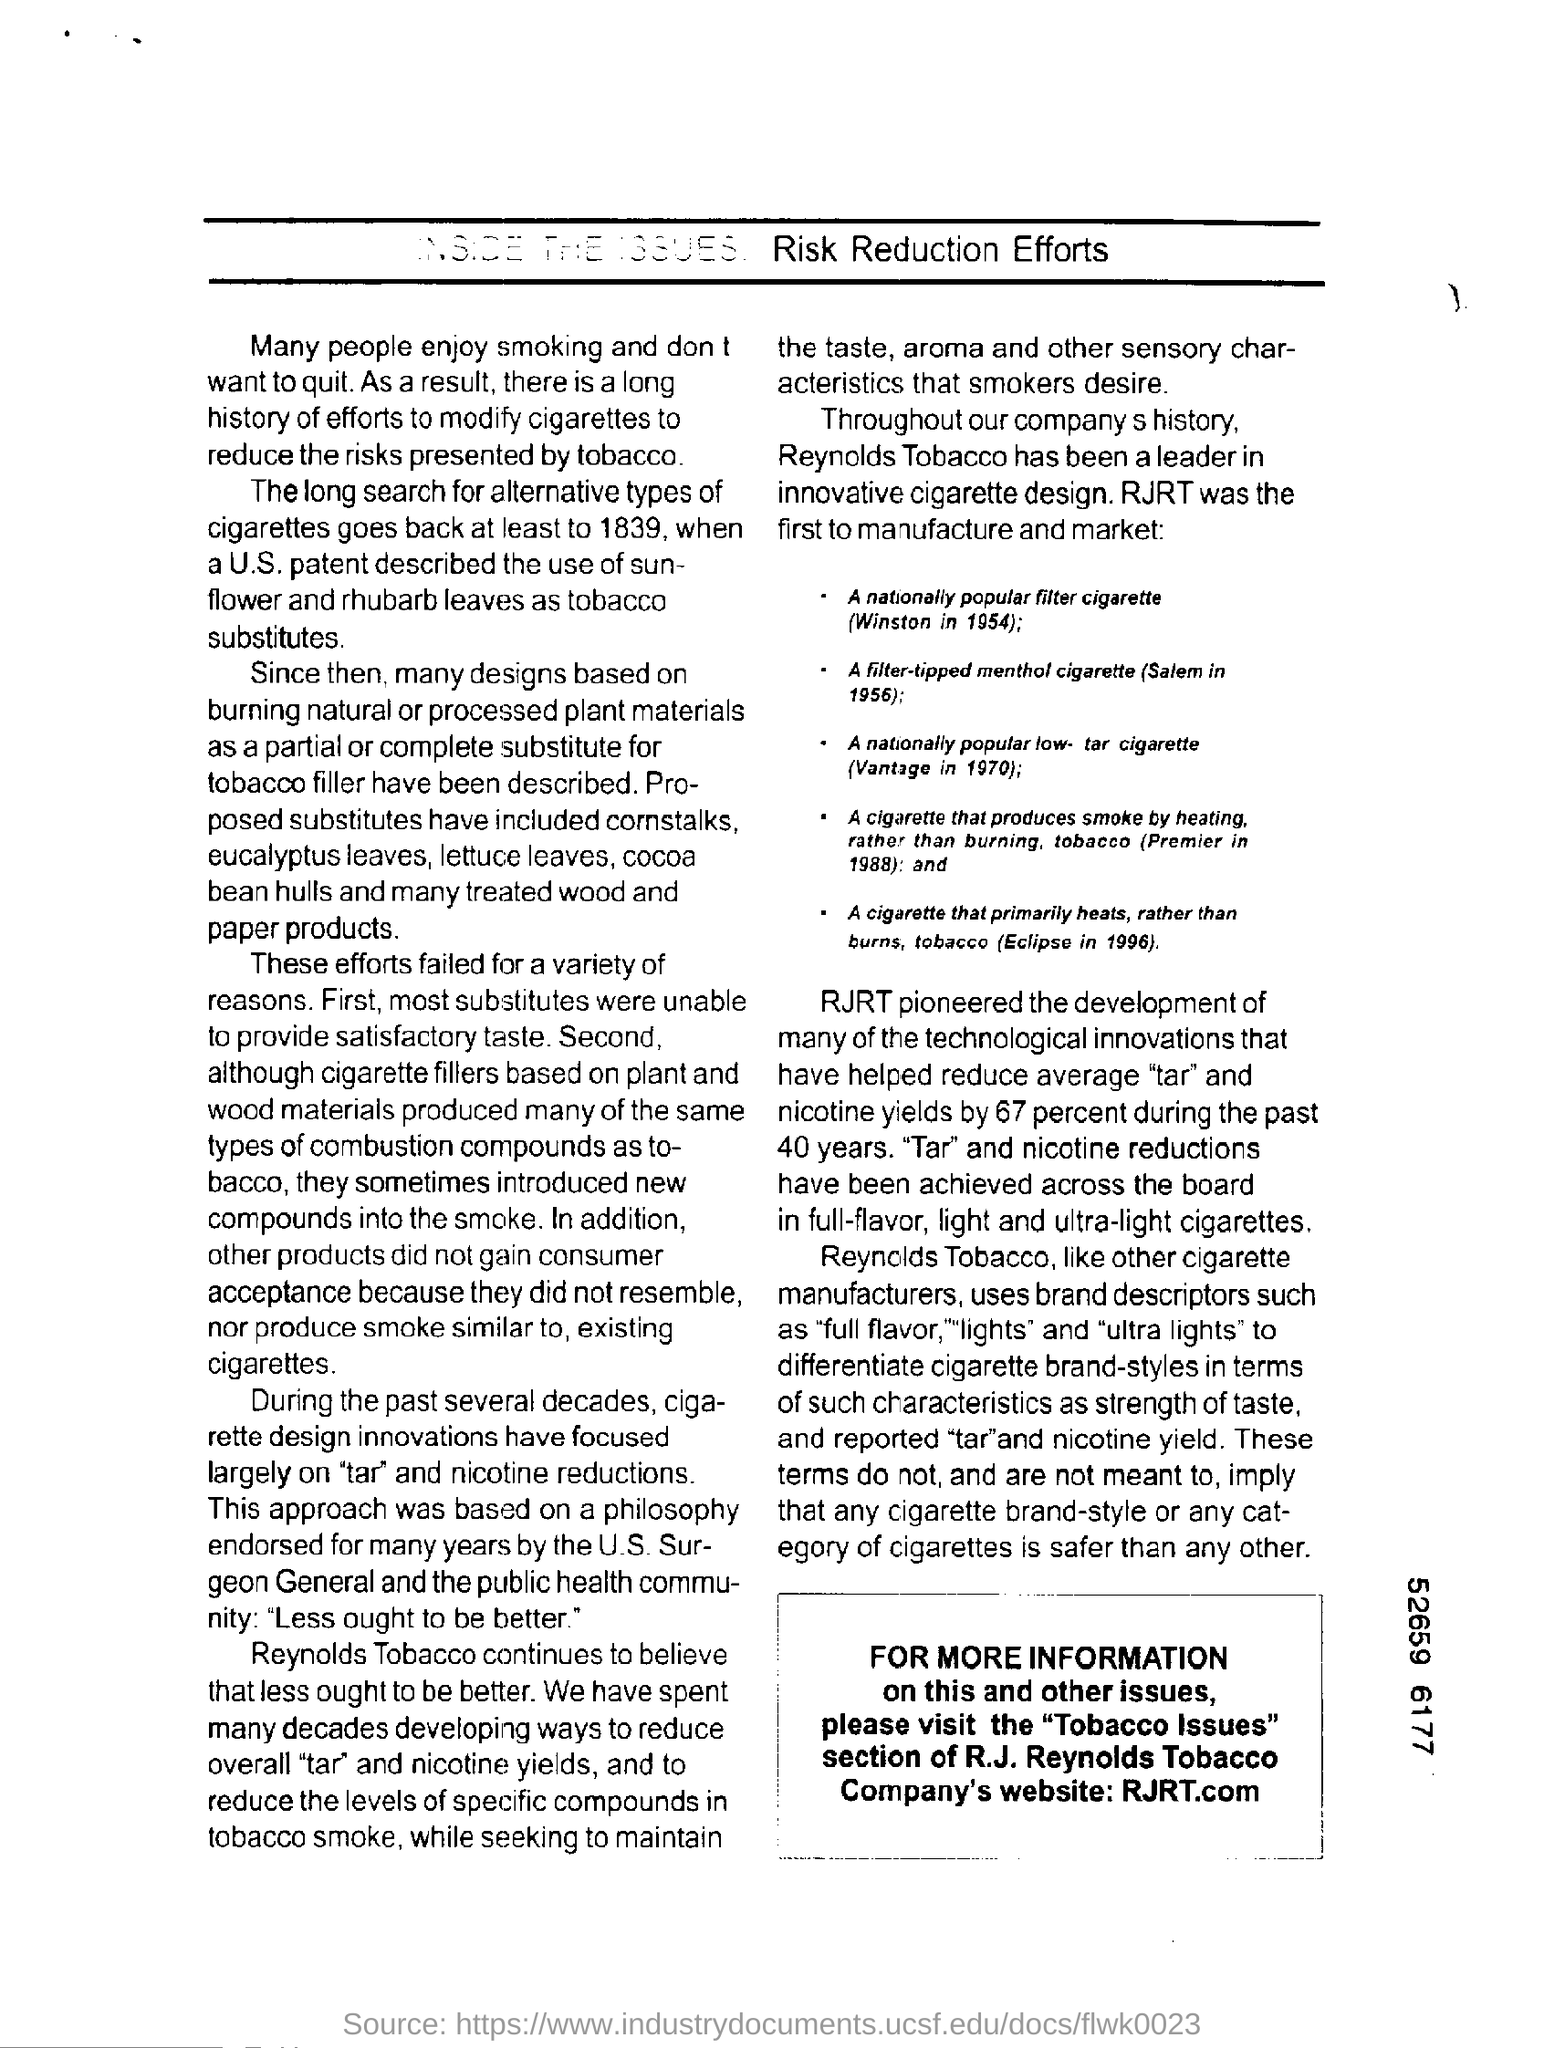Identify some key points in this picture. In 1954, RJ Reynolds Manufacturing Company produced a nationally popular filter cigarette. In recent years, the primary focus of cigarette design innovations has been on reducing tar and nicotine levels. It is recommended that the reader consult the section titled 'Tobacco Issues' for additional information. RJRT's company website is RJRT.com. Sunflower and rhubarb leaves are listed as viable tobacco substitutes in accordance with the U.S. patent. 